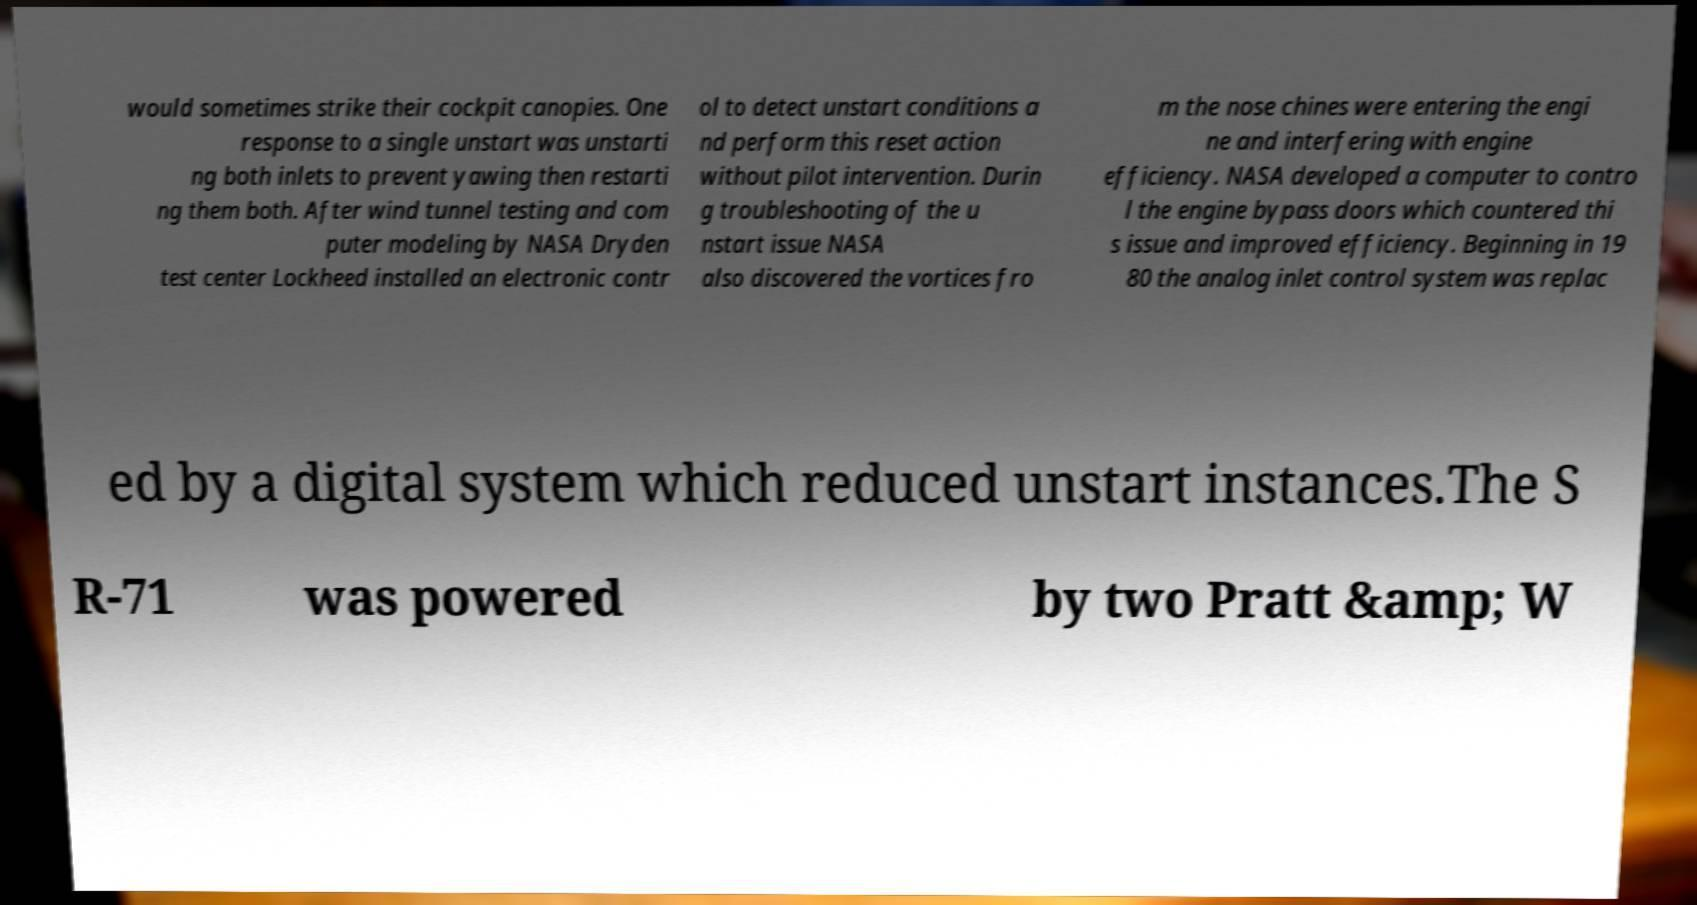I need the written content from this picture converted into text. Can you do that? would sometimes strike their cockpit canopies. One response to a single unstart was unstarti ng both inlets to prevent yawing then restarti ng them both. After wind tunnel testing and com puter modeling by NASA Dryden test center Lockheed installed an electronic contr ol to detect unstart conditions a nd perform this reset action without pilot intervention. Durin g troubleshooting of the u nstart issue NASA also discovered the vortices fro m the nose chines were entering the engi ne and interfering with engine efficiency. NASA developed a computer to contro l the engine bypass doors which countered thi s issue and improved efficiency. Beginning in 19 80 the analog inlet control system was replac ed by a digital system which reduced unstart instances.The S R-71 was powered by two Pratt &amp; W 